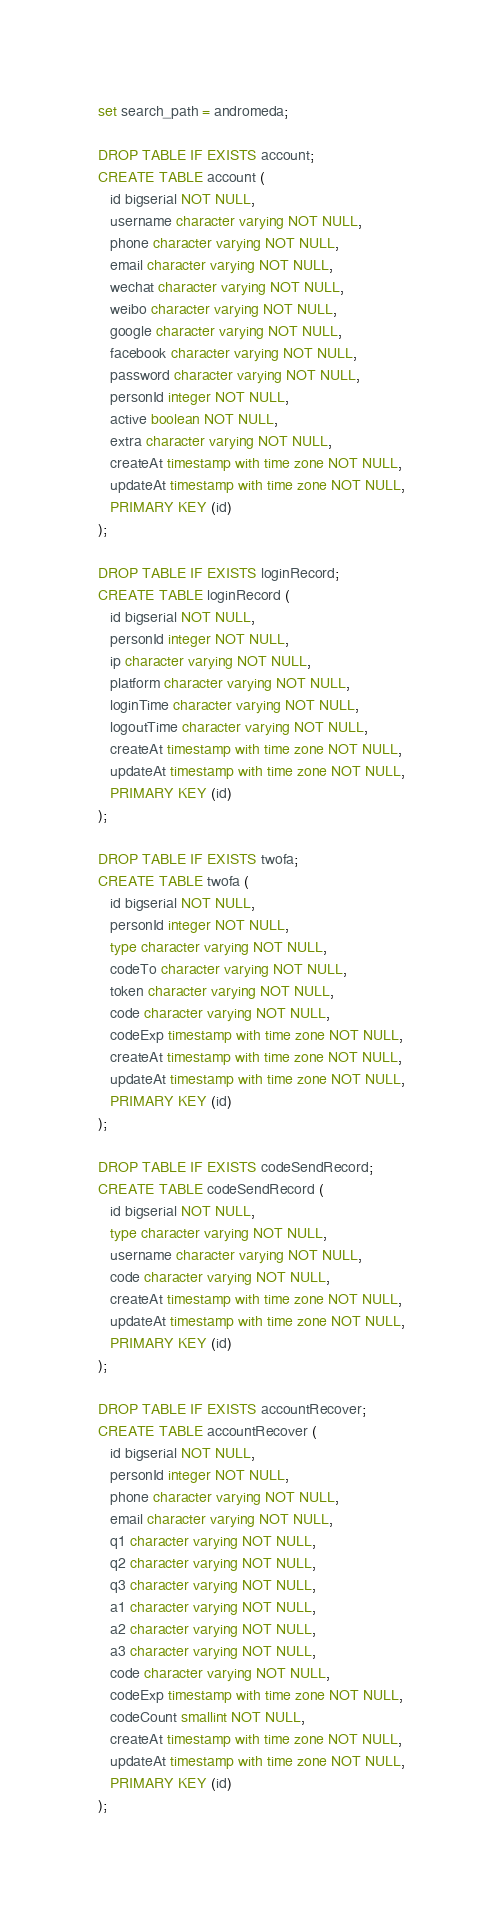Convert code to text. <code><loc_0><loc_0><loc_500><loc_500><_SQL_>set search_path = andromeda;

DROP TABLE IF EXISTS account;
CREATE TABLE account (
   id bigserial NOT NULL,
   username character varying NOT NULL,
   phone character varying NOT NULL,
   email character varying NOT NULL,
   wechat character varying NOT NULL,
   weibo character varying NOT NULL,
   google character varying NOT NULL,
   facebook character varying NOT NULL,
   password character varying NOT NULL,
   personId integer NOT NULL,
   active boolean NOT NULL,
   extra character varying NOT NULL,
   createAt timestamp with time zone NOT NULL,
   updateAt timestamp with time zone NOT NULL,
   PRIMARY KEY (id)
);

DROP TABLE IF EXISTS loginRecord;
CREATE TABLE loginRecord (
   id bigserial NOT NULL,
   personId integer NOT NULL,
   ip character varying NOT NULL,
   platform character varying NOT NULL,
   loginTime character varying NOT NULL,
   logoutTime character varying NOT NULL,
   createAt timestamp with time zone NOT NULL,
   updateAt timestamp with time zone NOT NULL,
   PRIMARY KEY (id)
);

DROP TABLE IF EXISTS twofa;
CREATE TABLE twofa (
   id bigserial NOT NULL,
   personId integer NOT NULL,
   type character varying NOT NULL,
   codeTo character varying NOT NULL,
   token character varying NOT NULL,
   code character varying NOT NULL,
   codeExp timestamp with time zone NOT NULL,
   createAt timestamp with time zone NOT NULL,
   updateAt timestamp with time zone NOT NULL,
   PRIMARY KEY (id)
);

DROP TABLE IF EXISTS codeSendRecord;
CREATE TABLE codeSendRecord (
   id bigserial NOT NULL,
   type character varying NOT NULL,
   username character varying NOT NULL,
   code character varying NOT NULL,
   createAt timestamp with time zone NOT NULL,
   updateAt timestamp with time zone NOT NULL,
   PRIMARY KEY (id)
);

DROP TABLE IF EXISTS accountRecover;
CREATE TABLE accountRecover (
   id bigserial NOT NULL,
   personId integer NOT NULL,
   phone character varying NOT NULL,
   email character varying NOT NULL,
   q1 character varying NOT NULL,
   q2 character varying NOT NULL,
   q3 character varying NOT NULL,
   a1 character varying NOT NULL,
   a2 character varying NOT NULL,
   a3 character varying NOT NULL,
   code character varying NOT NULL,
   codeExp timestamp with time zone NOT NULL,
   codeCount smallint NOT NULL,
   createAt timestamp with time zone NOT NULL,
   updateAt timestamp with time zone NOT NULL,
   PRIMARY KEY (id)
);
</code> 